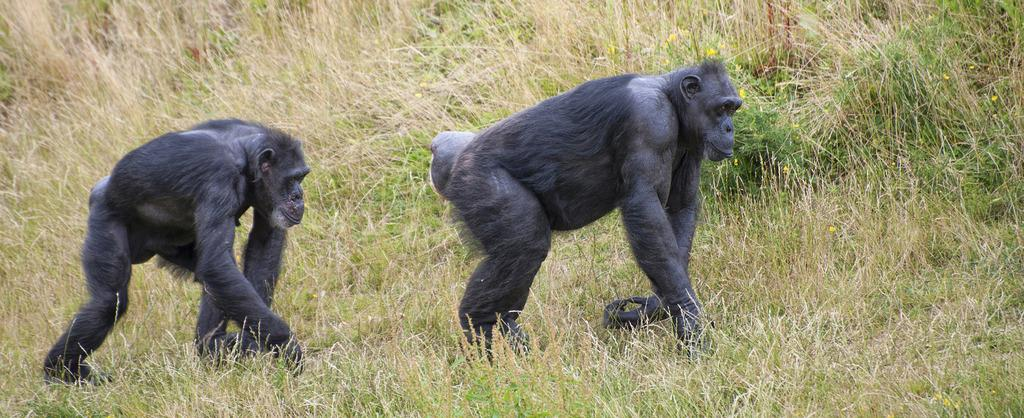What type of animals are in the image? There are chimpanzees in the image. What is the ground surface like in the image? There is grass in the image. Are there any plants visible in the image? Yes, there are flowers in the image. What type of turkey can be seen interacting with the chimpanzees in the image? There is no turkey present in the image; it features chimpanzees, grass, and flowers. What is the value of the chimpanzees in the image? The value of the chimpanzees cannot be determined from the image alone, as it does not provide any information about their worth or significance. 